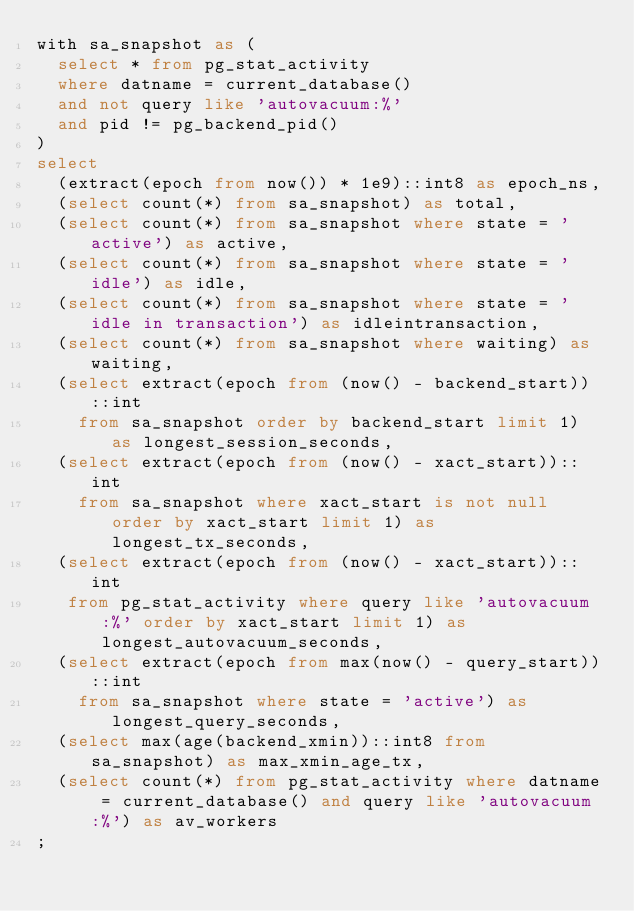<code> <loc_0><loc_0><loc_500><loc_500><_SQL_>with sa_snapshot as (
  select * from pg_stat_activity
  where datname = current_database()
  and not query like 'autovacuum:%'
  and pid != pg_backend_pid()
)
select
  (extract(epoch from now()) * 1e9)::int8 as epoch_ns,
  (select count(*) from sa_snapshot) as total,
  (select count(*) from sa_snapshot where state = 'active') as active,
  (select count(*) from sa_snapshot where state = 'idle') as idle,
  (select count(*) from sa_snapshot where state = 'idle in transaction') as idleintransaction,
  (select count(*) from sa_snapshot where waiting) as waiting,
  (select extract(epoch from (now() - backend_start))::int
    from sa_snapshot order by backend_start limit 1) as longest_session_seconds,
  (select extract(epoch from (now() - xact_start))::int
    from sa_snapshot where xact_start is not null order by xact_start limit 1) as longest_tx_seconds,
  (select extract(epoch from (now() - xact_start))::int
   from pg_stat_activity where query like 'autovacuum:%' order by xact_start limit 1) as longest_autovacuum_seconds,
  (select extract(epoch from max(now() - query_start))::int
    from sa_snapshot where state = 'active') as longest_query_seconds,
  (select max(age(backend_xmin))::int8 from sa_snapshot) as max_xmin_age_tx,
  (select count(*) from pg_stat_activity where datname = current_database() and query like 'autovacuum:%') as av_workers
;
</code> 